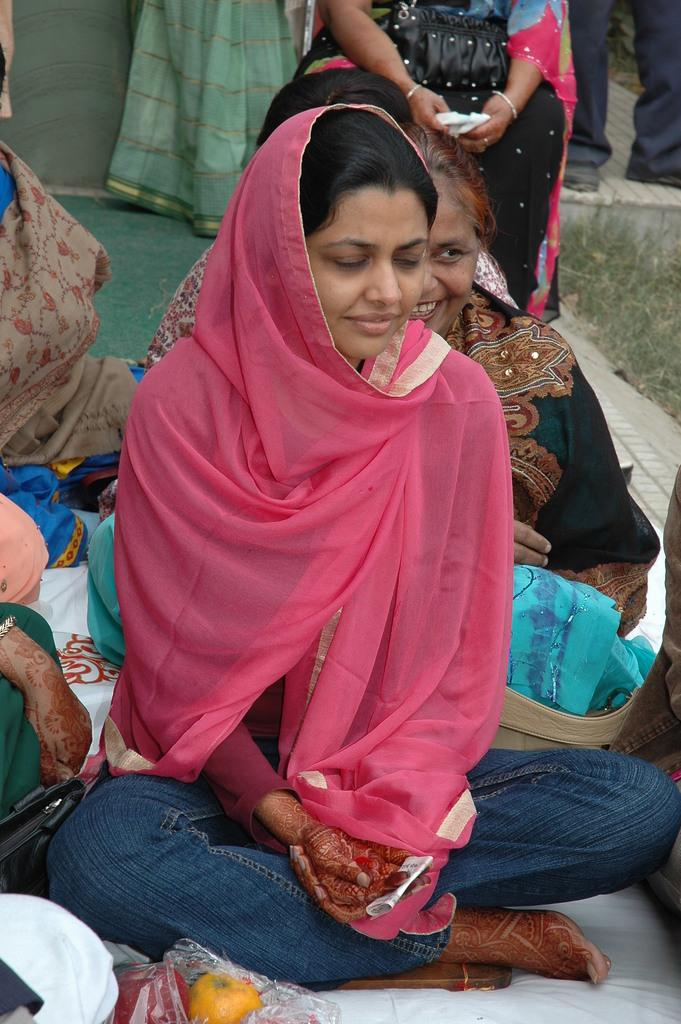What are the people in the image doing? The people in the image are sitting. Can you describe the people in the background of the image? There are people standing in the background of the image. What type of mitten is being used by the people in the image? There are no mittens present in the image; the people are not wearing any gloves or hand coverings. 